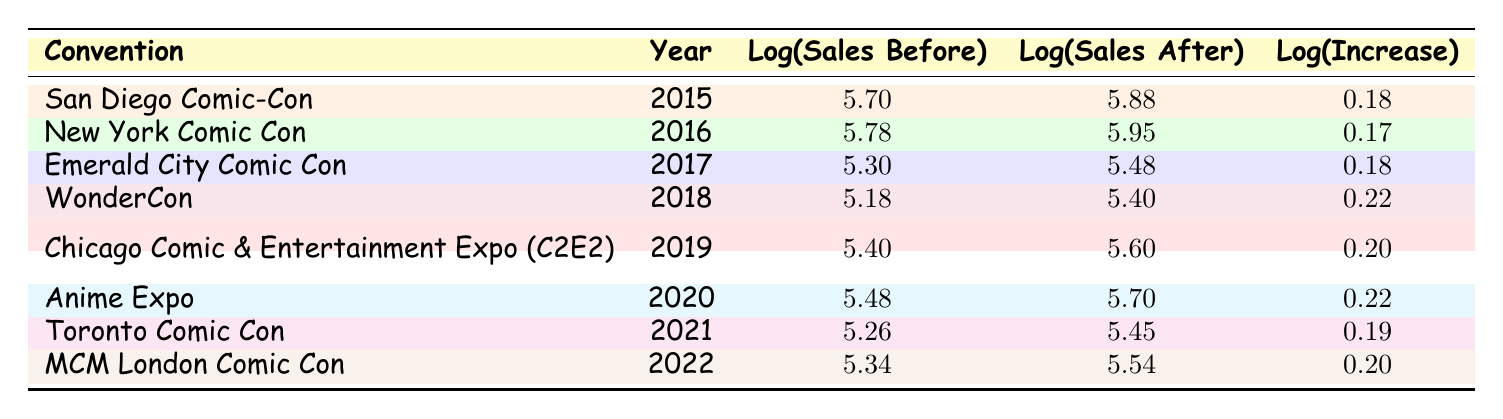What were the log sales figures before the San Diego Comic-Con in 2015? The log sales before the San Diego Comic-Con in 2015 is provided directly in the table under the "Log(Sales Before)" column for that row, which shows a value of 5.70.
Answer: 5.70 Which convention in 2022 had the highest log sales after? By comparing the values under the "Log(Sales After)" column for each convention in 2022, MCM London Comic Con has a value of 5.54, which is greater than any other convention's log sales after in that year. Therefore, it is the highest.
Answer: MCM London Comic Con What is the difference in log sales before and after the New York Comic Con in 2016? To find the difference, subtract the log sales before (5.78) from the log sales after (5.95) for the New York Comic Con. The calculation is 5.95 - 5.78 = 0.17.
Answer: 0.17 Is the log increase for the Chicago Comic & Entertainment Expo (C2E2) equal to 0.20? The table shows the log increase for Chicago Comic & Entertainment Expo (C2E2) as 0.20, confirming that the statement is true.
Answer: Yes What is the average log increase across all conventions in the table? To find the average log increase, sum all the log increases: (0.18 + 0.17 + 0.18 + 0.22 + 0.20 + 0.22 + 0.19 + 0.20) = 1.36. There are 8 conventions, so the average is 1.36 / 8 = 0.17.
Answer: 0.17 Which convention had the lowest sales before in 2017? In 2017, Emerald City Comic Con had log sales before of 5.30, which is the lowest compared to other conventions in that year.
Answer: Emerald City Comic Con Was there a log increase greater than 0.20 for any convention? By reviewing the table, both WonderCon and Anime Expo have log increases of 0.22, which confirms that there was a log increase greater than 0.20.
Answer: Yes Calculate the median of the log sales after for the conventions in the table. First, we list the log sales after values in numerical order: 5.45 (Toronto Comic Con), 5.48 (Emerald City Comic Con), 5.54 (MCM London Comic Con), 5.60 (C2E2), 5.70 (Anime Expo), 5.88 (San Diego Comic-Con), 5.95 (New York Comic Con), and 5.40 (WonderCon). The middle two values (5.54 and 5.70) are averaged: (5.54 + 5.70) / 2 = 5.62.
Answer: 5.62 